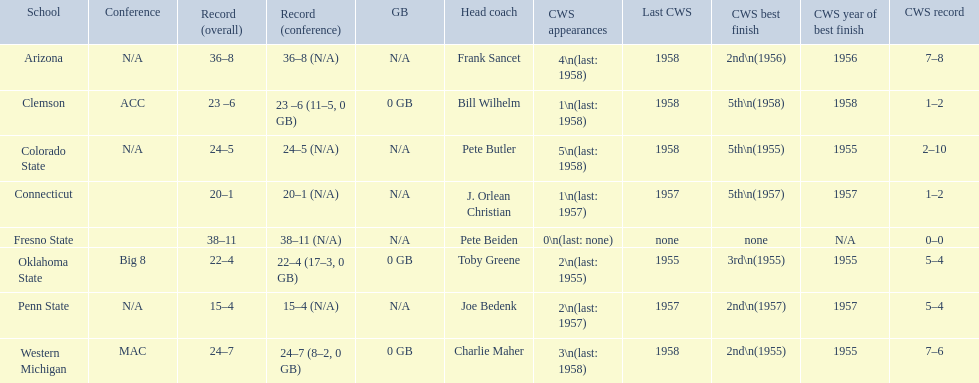What are the teams in the conference? Arizona, Clemson, Colorado State, Connecticut, Fresno State, Oklahoma State, Penn State, Western Michigan. Which have more than 16 wins? Arizona, Clemson, Colorado State, Connecticut, Fresno State, Oklahoma State, Western Michigan. Which had less than 16 wins? Penn State. 